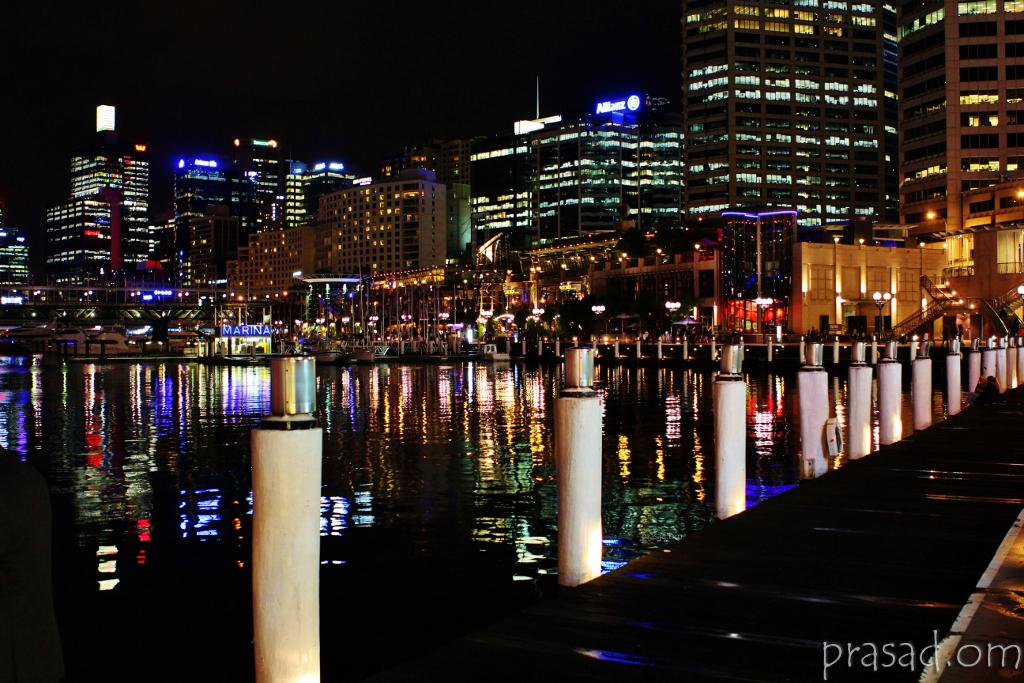What type of structures can be seen in the image? There are buildings in the image. What else is visible in the image besides the buildings? There are lights, boards, poles, and water visible in the image. Can you describe the water in the image? The water is visible at the bottom of the image. Is there any text present in the image? Yes, there is some text visible in the image. What type of thrill can be experienced by riding the train in the image? There is no train present in the image, so it is not possible to experience any thrill by riding it. 